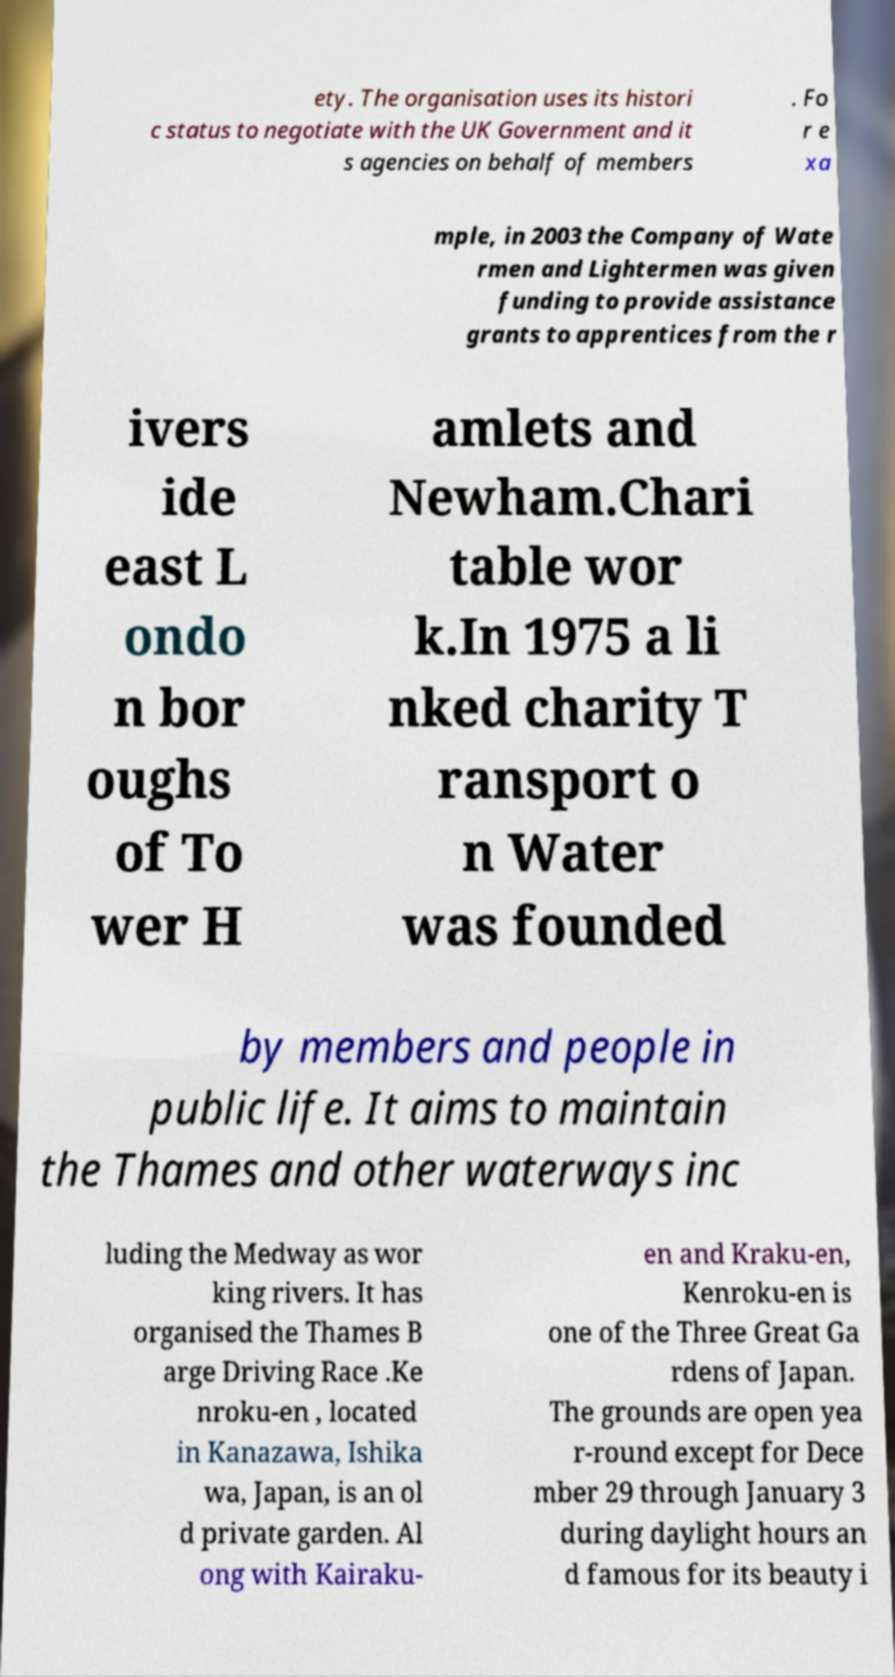Please read and relay the text visible in this image. What does it say? ety. The organisation uses its histori c status to negotiate with the UK Government and it s agencies on behalf of members . Fo r e xa mple, in 2003 the Company of Wate rmen and Lightermen was given funding to provide assistance grants to apprentices from the r ivers ide east L ondo n bor oughs of To wer H amlets and Newham.Chari table wor k.In 1975 a li nked charity T ransport o n Water was founded by members and people in public life. It aims to maintain the Thames and other waterways inc luding the Medway as wor king rivers. It has organised the Thames B arge Driving Race .Ke nroku-en , located in Kanazawa, Ishika wa, Japan, is an ol d private garden. Al ong with Kairaku- en and Kraku-en, Kenroku-en is one of the Three Great Ga rdens of Japan. The grounds are open yea r-round except for Dece mber 29 through January 3 during daylight hours an d famous for its beauty i 